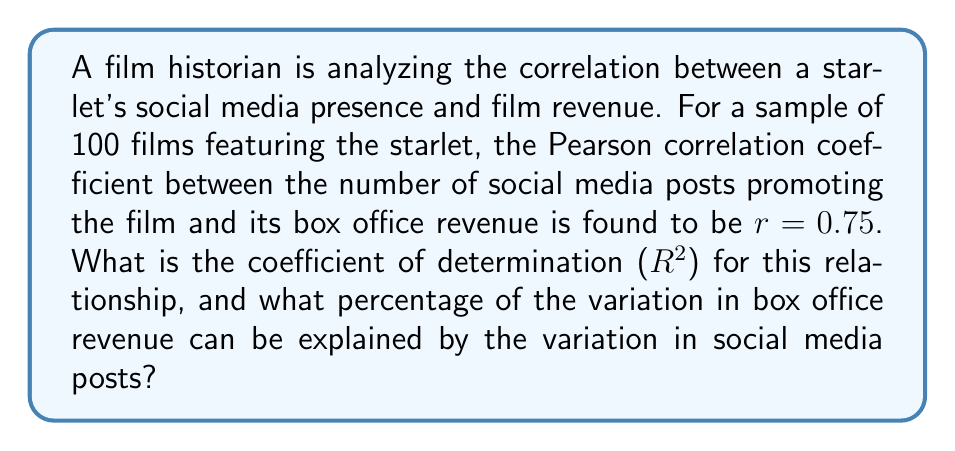Could you help me with this problem? To solve this problem, we'll follow these steps:

1. Recall that the coefficient of determination ($R^2$) is the square of the Pearson correlation coefficient ($r$).

2. Calculate $R^2$:
   $$R^2 = r^2 = (0.75)^2 = 0.5625$$

3. Convert $R^2$ to a percentage:
   $$0.5625 \times 100\% = 56.25\%$$

4. Interpret the result: The coefficient of determination ($R^2$) of 0.5625 means that 56.25% of the variation in box office revenue can be explained by the variation in social media posts.

This analysis suggests a moderate to strong relationship between the starlet's social media presence and film revenue, which could be valuable information for film producers and marketers in the industry.
Answer: $R^2 = 0.5625$; 56.25% of variation explained 